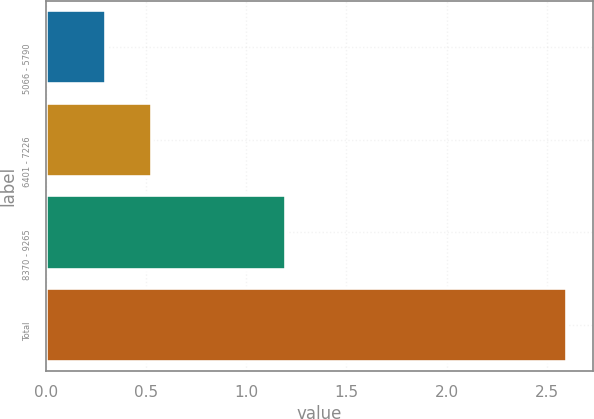Convert chart. <chart><loc_0><loc_0><loc_500><loc_500><bar_chart><fcel>5066 - 5790<fcel>6401 - 7226<fcel>8370 - 9265<fcel>Total<nl><fcel>0.3<fcel>0.53<fcel>1.2<fcel>2.6<nl></chart> 